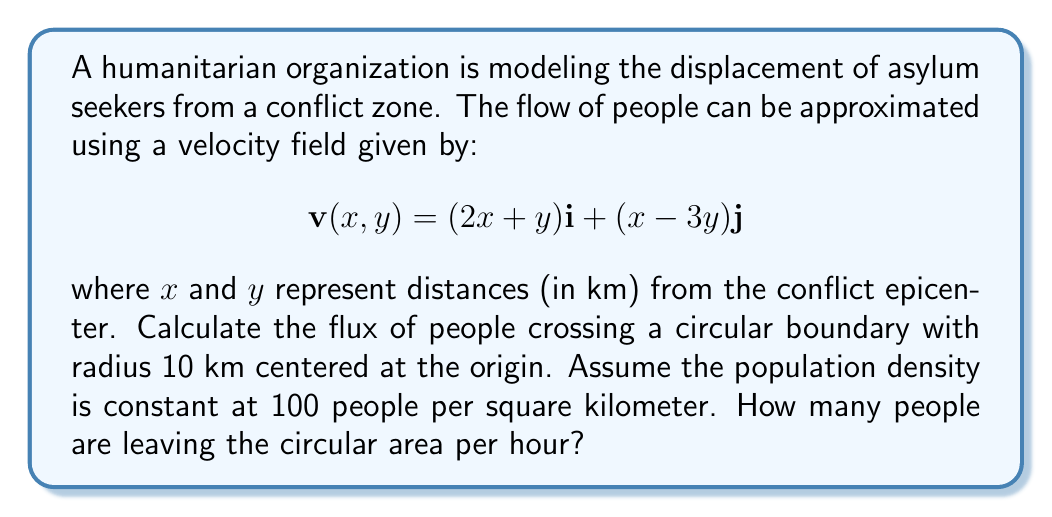Help me with this question. To solve this problem, we'll use the divergence theorem and concepts from vector calculus. Let's break it down step-by-step:

1) The divergence theorem states that the flux across a closed surface is equal to the volume integral of the divergence of the vector field within the enclosed volume:

   $$\oint_S \mathbf{v} \cdot \mathbf{n} \, dS = \int_V \nabla \cdot \mathbf{v} \, dV$$

2) First, we need to calculate the divergence of the velocity field:

   $$\nabla \cdot \mathbf{v} = \frac{\partial}{\partial x}(2x + y) + \frac{\partial}{\partial y}(x - 3y) = 2 - 3 = -1$$

3) The divergence is constant, so the volume integral simplifies to:

   $$\int_V \nabla \cdot \mathbf{v} \, dV = -1 \cdot \text{Volume}$$

4) The volume of the circular area is:

   $$\text{Volume} = \pi r^2 = \pi \cdot 10^2 = 100\pi \text{ km}^2$$

5) Therefore, the flux (in km²/hour) is:

   $$\text{Flux} = -1 \cdot 100\pi = -100\pi \text{ km}^2/\text{hour}$$

6) The negative sign indicates that the net flow is inward (people are moving towards the center of the conflict zone). However, we're interested in the outward flow of asylum seekers, so we'll take the absolute value.

7) To find the number of people leaving per hour, we multiply the flux by the population density:

   $$\text{People leaving} = |100\pi| \cdot 100 \text{ people/km}^2 = 10000\pi \text{ people/hour}$$
Answer: Approximately 31,416 people are leaving the circular area per hour. 